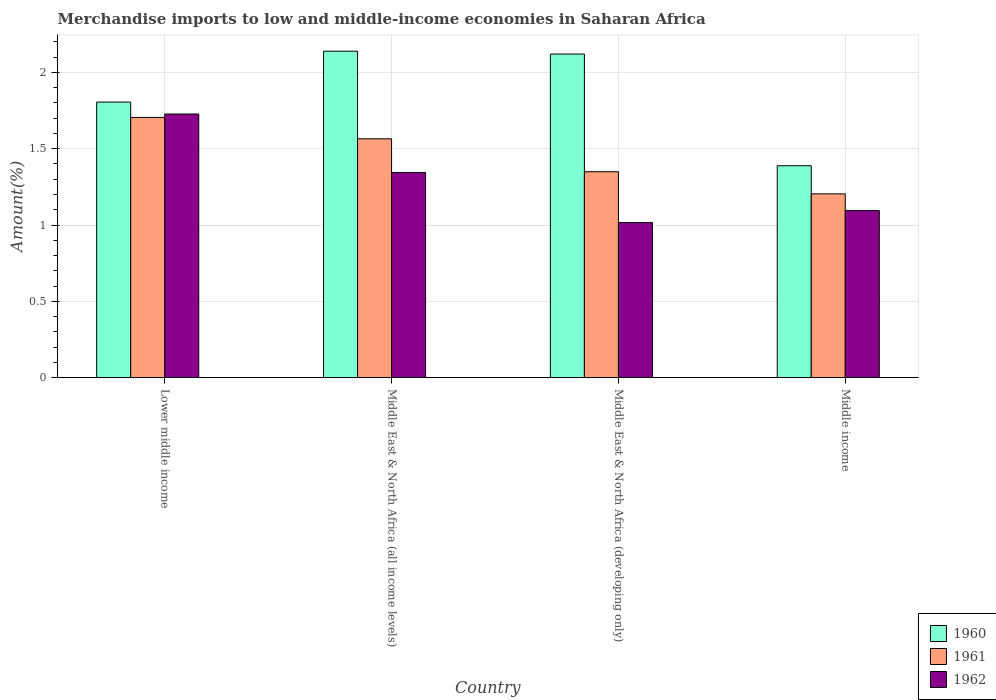How many different coloured bars are there?
Provide a short and direct response. 3. Are the number of bars per tick equal to the number of legend labels?
Provide a succinct answer. Yes. Are the number of bars on each tick of the X-axis equal?
Provide a short and direct response. Yes. What is the label of the 2nd group of bars from the left?
Offer a terse response. Middle East & North Africa (all income levels). In how many cases, is the number of bars for a given country not equal to the number of legend labels?
Your answer should be compact. 0. What is the percentage of amount earned from merchandise imports in 1960 in Middle East & North Africa (developing only)?
Offer a very short reply. 2.12. Across all countries, what is the maximum percentage of amount earned from merchandise imports in 1961?
Provide a succinct answer. 1.71. Across all countries, what is the minimum percentage of amount earned from merchandise imports in 1961?
Your response must be concise. 1.2. In which country was the percentage of amount earned from merchandise imports in 1960 maximum?
Offer a very short reply. Middle East & North Africa (all income levels). In which country was the percentage of amount earned from merchandise imports in 1960 minimum?
Your answer should be compact. Middle income. What is the total percentage of amount earned from merchandise imports in 1962 in the graph?
Make the answer very short. 5.18. What is the difference between the percentage of amount earned from merchandise imports in 1960 in Middle East & North Africa (all income levels) and that in Middle East & North Africa (developing only)?
Make the answer very short. 0.02. What is the difference between the percentage of amount earned from merchandise imports in 1962 in Middle East & North Africa (all income levels) and the percentage of amount earned from merchandise imports in 1960 in Middle income?
Give a very brief answer. -0.04. What is the average percentage of amount earned from merchandise imports in 1962 per country?
Your answer should be very brief. 1.3. What is the difference between the percentage of amount earned from merchandise imports of/in 1962 and percentage of amount earned from merchandise imports of/in 1960 in Middle East & North Africa (developing only)?
Keep it short and to the point. -1.1. In how many countries, is the percentage of amount earned from merchandise imports in 1960 greater than 1.9 %?
Offer a very short reply. 2. What is the ratio of the percentage of amount earned from merchandise imports in 1962 in Lower middle income to that in Middle income?
Make the answer very short. 1.58. Is the percentage of amount earned from merchandise imports in 1961 in Lower middle income less than that in Middle income?
Give a very brief answer. No. What is the difference between the highest and the second highest percentage of amount earned from merchandise imports in 1960?
Provide a short and direct response. -0.33. What is the difference between the highest and the lowest percentage of amount earned from merchandise imports in 1960?
Offer a terse response. 0.75. Is the sum of the percentage of amount earned from merchandise imports in 1962 in Lower middle income and Middle East & North Africa (all income levels) greater than the maximum percentage of amount earned from merchandise imports in 1960 across all countries?
Ensure brevity in your answer.  Yes. What does the 1st bar from the right in Middle income represents?
Provide a short and direct response. 1962. How many bars are there?
Make the answer very short. 12. Are all the bars in the graph horizontal?
Your answer should be very brief. No. Are the values on the major ticks of Y-axis written in scientific E-notation?
Your answer should be compact. No. Does the graph contain any zero values?
Give a very brief answer. No. Where does the legend appear in the graph?
Your answer should be compact. Bottom right. How many legend labels are there?
Offer a terse response. 3. What is the title of the graph?
Offer a very short reply. Merchandise imports to low and middle-income economies in Saharan Africa. What is the label or title of the Y-axis?
Your answer should be compact. Amount(%). What is the Amount(%) in 1960 in Lower middle income?
Provide a short and direct response. 1.81. What is the Amount(%) in 1961 in Lower middle income?
Offer a very short reply. 1.71. What is the Amount(%) of 1962 in Lower middle income?
Provide a succinct answer. 1.73. What is the Amount(%) of 1960 in Middle East & North Africa (all income levels)?
Offer a very short reply. 2.14. What is the Amount(%) of 1961 in Middle East & North Africa (all income levels)?
Your answer should be very brief. 1.57. What is the Amount(%) of 1962 in Middle East & North Africa (all income levels)?
Provide a short and direct response. 1.34. What is the Amount(%) in 1960 in Middle East & North Africa (developing only)?
Make the answer very short. 2.12. What is the Amount(%) of 1961 in Middle East & North Africa (developing only)?
Give a very brief answer. 1.35. What is the Amount(%) in 1962 in Middle East & North Africa (developing only)?
Make the answer very short. 1.02. What is the Amount(%) of 1960 in Middle income?
Give a very brief answer. 1.39. What is the Amount(%) of 1961 in Middle income?
Make the answer very short. 1.2. What is the Amount(%) in 1962 in Middle income?
Provide a short and direct response. 1.1. Across all countries, what is the maximum Amount(%) in 1960?
Offer a terse response. 2.14. Across all countries, what is the maximum Amount(%) of 1961?
Your answer should be compact. 1.71. Across all countries, what is the maximum Amount(%) in 1962?
Offer a terse response. 1.73. Across all countries, what is the minimum Amount(%) in 1960?
Keep it short and to the point. 1.39. Across all countries, what is the minimum Amount(%) in 1961?
Give a very brief answer. 1.2. Across all countries, what is the minimum Amount(%) of 1962?
Your answer should be compact. 1.02. What is the total Amount(%) of 1960 in the graph?
Provide a succinct answer. 7.45. What is the total Amount(%) of 1961 in the graph?
Your answer should be compact. 5.82. What is the total Amount(%) of 1962 in the graph?
Make the answer very short. 5.18. What is the difference between the Amount(%) in 1960 in Lower middle income and that in Middle East & North Africa (all income levels)?
Ensure brevity in your answer.  -0.33. What is the difference between the Amount(%) in 1961 in Lower middle income and that in Middle East & North Africa (all income levels)?
Ensure brevity in your answer.  0.14. What is the difference between the Amount(%) of 1962 in Lower middle income and that in Middle East & North Africa (all income levels)?
Your answer should be compact. 0.38. What is the difference between the Amount(%) in 1960 in Lower middle income and that in Middle East & North Africa (developing only)?
Provide a succinct answer. -0.31. What is the difference between the Amount(%) of 1961 in Lower middle income and that in Middle East & North Africa (developing only)?
Provide a short and direct response. 0.36. What is the difference between the Amount(%) of 1962 in Lower middle income and that in Middle East & North Africa (developing only)?
Give a very brief answer. 0.71. What is the difference between the Amount(%) in 1960 in Lower middle income and that in Middle income?
Give a very brief answer. 0.42. What is the difference between the Amount(%) of 1961 in Lower middle income and that in Middle income?
Ensure brevity in your answer.  0.5. What is the difference between the Amount(%) in 1962 in Lower middle income and that in Middle income?
Offer a terse response. 0.63. What is the difference between the Amount(%) in 1960 in Middle East & North Africa (all income levels) and that in Middle East & North Africa (developing only)?
Your response must be concise. 0.02. What is the difference between the Amount(%) of 1961 in Middle East & North Africa (all income levels) and that in Middle East & North Africa (developing only)?
Make the answer very short. 0.22. What is the difference between the Amount(%) in 1962 in Middle East & North Africa (all income levels) and that in Middle East & North Africa (developing only)?
Offer a terse response. 0.33. What is the difference between the Amount(%) of 1960 in Middle East & North Africa (all income levels) and that in Middle income?
Make the answer very short. 0.75. What is the difference between the Amount(%) of 1961 in Middle East & North Africa (all income levels) and that in Middle income?
Give a very brief answer. 0.36. What is the difference between the Amount(%) in 1962 in Middle East & North Africa (all income levels) and that in Middle income?
Your response must be concise. 0.25. What is the difference between the Amount(%) in 1960 in Middle East & North Africa (developing only) and that in Middle income?
Make the answer very short. 0.73. What is the difference between the Amount(%) in 1961 in Middle East & North Africa (developing only) and that in Middle income?
Provide a short and direct response. 0.15. What is the difference between the Amount(%) in 1962 in Middle East & North Africa (developing only) and that in Middle income?
Your response must be concise. -0.08. What is the difference between the Amount(%) in 1960 in Lower middle income and the Amount(%) in 1961 in Middle East & North Africa (all income levels)?
Your answer should be very brief. 0.24. What is the difference between the Amount(%) in 1960 in Lower middle income and the Amount(%) in 1962 in Middle East & North Africa (all income levels)?
Provide a short and direct response. 0.46. What is the difference between the Amount(%) of 1961 in Lower middle income and the Amount(%) of 1962 in Middle East & North Africa (all income levels)?
Make the answer very short. 0.36. What is the difference between the Amount(%) in 1960 in Lower middle income and the Amount(%) in 1961 in Middle East & North Africa (developing only)?
Your answer should be very brief. 0.46. What is the difference between the Amount(%) of 1960 in Lower middle income and the Amount(%) of 1962 in Middle East & North Africa (developing only)?
Offer a very short reply. 0.79. What is the difference between the Amount(%) in 1961 in Lower middle income and the Amount(%) in 1962 in Middle East & North Africa (developing only)?
Offer a very short reply. 0.69. What is the difference between the Amount(%) in 1960 in Lower middle income and the Amount(%) in 1961 in Middle income?
Keep it short and to the point. 0.6. What is the difference between the Amount(%) of 1960 in Lower middle income and the Amount(%) of 1962 in Middle income?
Keep it short and to the point. 0.71. What is the difference between the Amount(%) of 1961 in Lower middle income and the Amount(%) of 1962 in Middle income?
Your answer should be compact. 0.61. What is the difference between the Amount(%) in 1960 in Middle East & North Africa (all income levels) and the Amount(%) in 1961 in Middle East & North Africa (developing only)?
Ensure brevity in your answer.  0.79. What is the difference between the Amount(%) of 1960 in Middle East & North Africa (all income levels) and the Amount(%) of 1962 in Middle East & North Africa (developing only)?
Offer a very short reply. 1.12. What is the difference between the Amount(%) in 1961 in Middle East & North Africa (all income levels) and the Amount(%) in 1962 in Middle East & North Africa (developing only)?
Your answer should be compact. 0.55. What is the difference between the Amount(%) in 1960 in Middle East & North Africa (all income levels) and the Amount(%) in 1961 in Middle income?
Ensure brevity in your answer.  0.93. What is the difference between the Amount(%) in 1960 in Middle East & North Africa (all income levels) and the Amount(%) in 1962 in Middle income?
Provide a short and direct response. 1.04. What is the difference between the Amount(%) in 1961 in Middle East & North Africa (all income levels) and the Amount(%) in 1962 in Middle income?
Your answer should be compact. 0.47. What is the difference between the Amount(%) of 1960 in Middle East & North Africa (developing only) and the Amount(%) of 1961 in Middle income?
Your answer should be very brief. 0.92. What is the difference between the Amount(%) of 1960 in Middle East & North Africa (developing only) and the Amount(%) of 1962 in Middle income?
Provide a succinct answer. 1.03. What is the difference between the Amount(%) of 1961 in Middle East & North Africa (developing only) and the Amount(%) of 1962 in Middle income?
Make the answer very short. 0.25. What is the average Amount(%) of 1960 per country?
Your answer should be very brief. 1.86. What is the average Amount(%) of 1961 per country?
Give a very brief answer. 1.46. What is the average Amount(%) of 1962 per country?
Offer a very short reply. 1.3. What is the difference between the Amount(%) of 1960 and Amount(%) of 1961 in Lower middle income?
Give a very brief answer. 0.1. What is the difference between the Amount(%) of 1960 and Amount(%) of 1962 in Lower middle income?
Keep it short and to the point. 0.08. What is the difference between the Amount(%) of 1961 and Amount(%) of 1962 in Lower middle income?
Your answer should be very brief. -0.02. What is the difference between the Amount(%) of 1960 and Amount(%) of 1961 in Middle East & North Africa (all income levels)?
Your answer should be very brief. 0.57. What is the difference between the Amount(%) of 1960 and Amount(%) of 1962 in Middle East & North Africa (all income levels)?
Your response must be concise. 0.79. What is the difference between the Amount(%) in 1961 and Amount(%) in 1962 in Middle East & North Africa (all income levels)?
Your answer should be compact. 0.22. What is the difference between the Amount(%) of 1960 and Amount(%) of 1961 in Middle East & North Africa (developing only)?
Your answer should be compact. 0.77. What is the difference between the Amount(%) of 1960 and Amount(%) of 1962 in Middle East & North Africa (developing only)?
Provide a succinct answer. 1.1. What is the difference between the Amount(%) in 1961 and Amount(%) in 1962 in Middle East & North Africa (developing only)?
Your answer should be very brief. 0.33. What is the difference between the Amount(%) in 1960 and Amount(%) in 1961 in Middle income?
Keep it short and to the point. 0.18. What is the difference between the Amount(%) in 1960 and Amount(%) in 1962 in Middle income?
Your answer should be compact. 0.29. What is the difference between the Amount(%) in 1961 and Amount(%) in 1962 in Middle income?
Provide a short and direct response. 0.11. What is the ratio of the Amount(%) of 1960 in Lower middle income to that in Middle East & North Africa (all income levels)?
Ensure brevity in your answer.  0.84. What is the ratio of the Amount(%) of 1961 in Lower middle income to that in Middle East & North Africa (all income levels)?
Your response must be concise. 1.09. What is the ratio of the Amount(%) of 1962 in Lower middle income to that in Middle East & North Africa (all income levels)?
Your answer should be very brief. 1.28. What is the ratio of the Amount(%) of 1960 in Lower middle income to that in Middle East & North Africa (developing only)?
Keep it short and to the point. 0.85. What is the ratio of the Amount(%) of 1961 in Lower middle income to that in Middle East & North Africa (developing only)?
Provide a short and direct response. 1.26. What is the ratio of the Amount(%) of 1962 in Lower middle income to that in Middle East & North Africa (developing only)?
Give a very brief answer. 1.7. What is the ratio of the Amount(%) of 1960 in Lower middle income to that in Middle income?
Provide a short and direct response. 1.3. What is the ratio of the Amount(%) of 1961 in Lower middle income to that in Middle income?
Offer a terse response. 1.42. What is the ratio of the Amount(%) of 1962 in Lower middle income to that in Middle income?
Give a very brief answer. 1.58. What is the ratio of the Amount(%) of 1960 in Middle East & North Africa (all income levels) to that in Middle East & North Africa (developing only)?
Offer a terse response. 1.01. What is the ratio of the Amount(%) of 1961 in Middle East & North Africa (all income levels) to that in Middle East & North Africa (developing only)?
Make the answer very short. 1.16. What is the ratio of the Amount(%) in 1962 in Middle East & North Africa (all income levels) to that in Middle East & North Africa (developing only)?
Make the answer very short. 1.32. What is the ratio of the Amount(%) in 1960 in Middle East & North Africa (all income levels) to that in Middle income?
Provide a short and direct response. 1.54. What is the ratio of the Amount(%) in 1961 in Middle East & North Africa (all income levels) to that in Middle income?
Keep it short and to the point. 1.3. What is the ratio of the Amount(%) in 1962 in Middle East & North Africa (all income levels) to that in Middle income?
Make the answer very short. 1.23. What is the ratio of the Amount(%) in 1960 in Middle East & North Africa (developing only) to that in Middle income?
Your response must be concise. 1.53. What is the ratio of the Amount(%) in 1961 in Middle East & North Africa (developing only) to that in Middle income?
Your answer should be very brief. 1.12. What is the ratio of the Amount(%) of 1962 in Middle East & North Africa (developing only) to that in Middle income?
Give a very brief answer. 0.93. What is the difference between the highest and the second highest Amount(%) in 1960?
Your answer should be compact. 0.02. What is the difference between the highest and the second highest Amount(%) of 1961?
Provide a succinct answer. 0.14. What is the difference between the highest and the second highest Amount(%) of 1962?
Your answer should be very brief. 0.38. What is the difference between the highest and the lowest Amount(%) in 1960?
Your answer should be compact. 0.75. What is the difference between the highest and the lowest Amount(%) of 1961?
Give a very brief answer. 0.5. What is the difference between the highest and the lowest Amount(%) in 1962?
Provide a succinct answer. 0.71. 